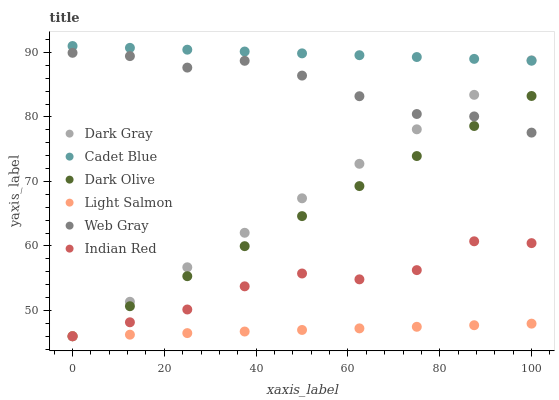Does Light Salmon have the minimum area under the curve?
Answer yes or no. Yes. Does Cadet Blue have the maximum area under the curve?
Answer yes or no. Yes. Does Dark Olive have the minimum area under the curve?
Answer yes or no. No. Does Dark Olive have the maximum area under the curve?
Answer yes or no. No. Is Light Salmon the smoothest?
Answer yes or no. Yes. Is Indian Red the roughest?
Answer yes or no. Yes. Is Cadet Blue the smoothest?
Answer yes or no. No. Is Cadet Blue the roughest?
Answer yes or no. No. Does Light Salmon have the lowest value?
Answer yes or no. Yes. Does Cadet Blue have the lowest value?
Answer yes or no. No. Does Cadet Blue have the highest value?
Answer yes or no. Yes. Does Dark Olive have the highest value?
Answer yes or no. No. Is Web Gray less than Cadet Blue?
Answer yes or no. Yes. Is Web Gray greater than Indian Red?
Answer yes or no. Yes. Does Dark Gray intersect Dark Olive?
Answer yes or no. Yes. Is Dark Gray less than Dark Olive?
Answer yes or no. No. Is Dark Gray greater than Dark Olive?
Answer yes or no. No. Does Web Gray intersect Cadet Blue?
Answer yes or no. No. 